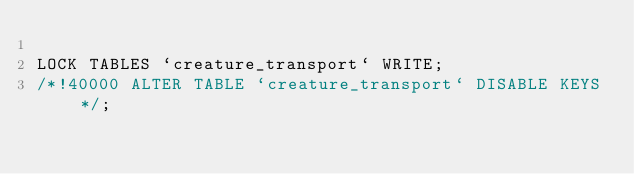<code> <loc_0><loc_0><loc_500><loc_500><_SQL_>
LOCK TABLES `creature_transport` WRITE;
/*!40000 ALTER TABLE `creature_transport` DISABLE KEYS */;</code> 